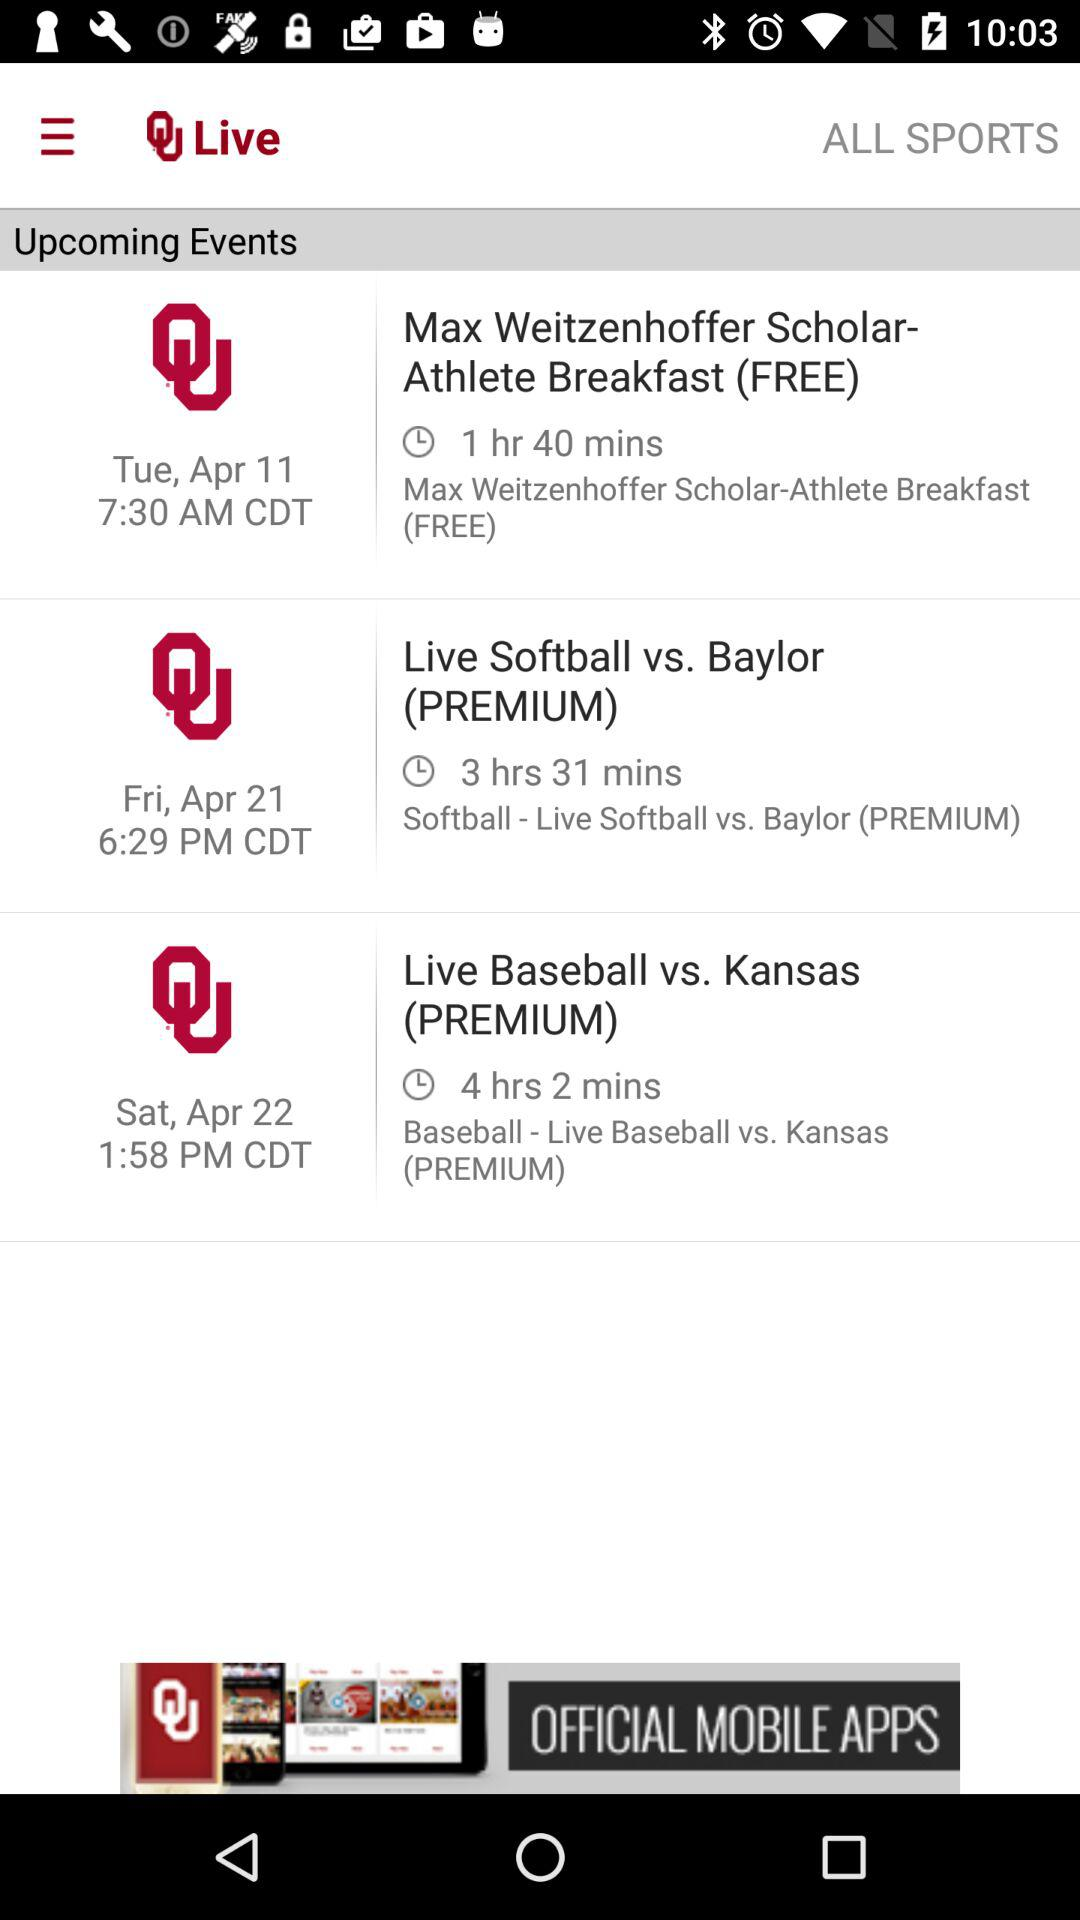What is the time duration of the event "Live Softball vs. Baylor (PREMIUM)"? The time duration is 3 hours 31 minutes. 